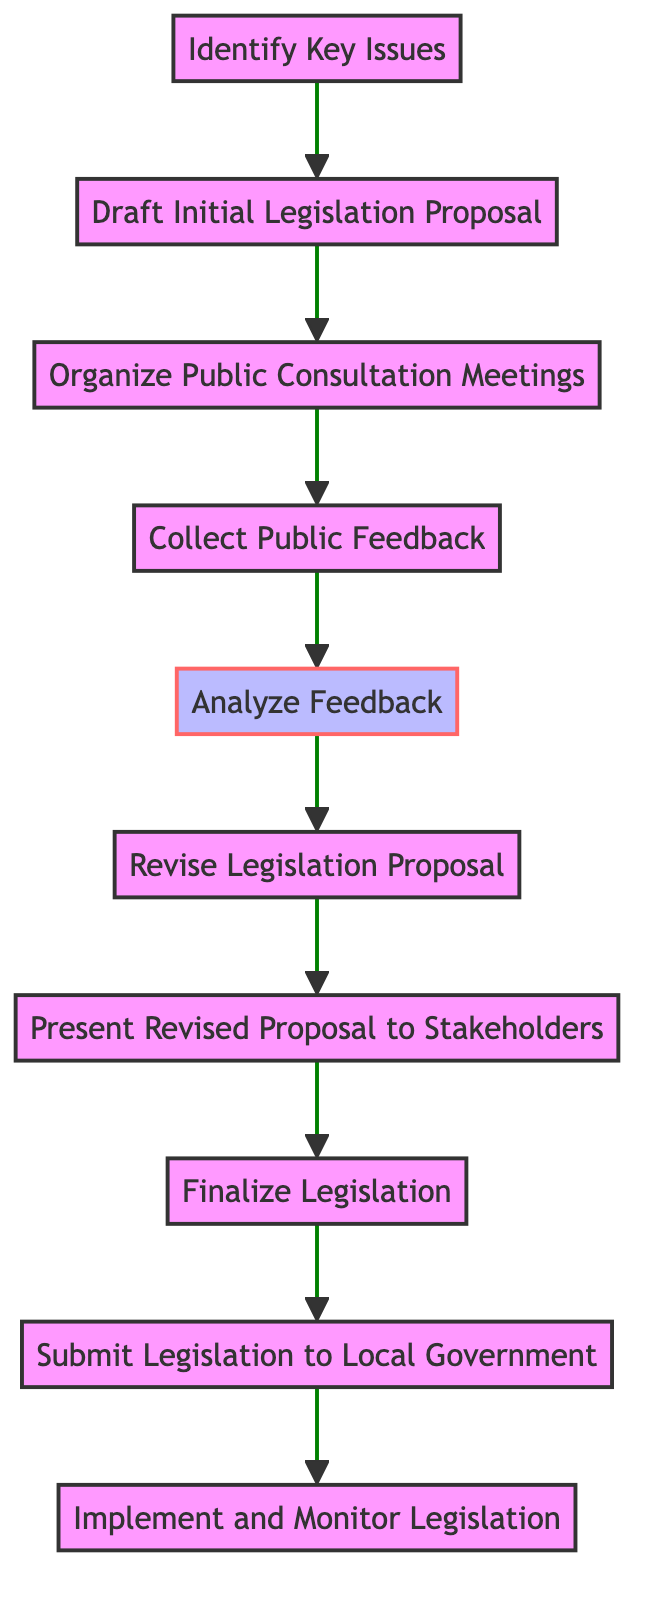What is the first activity in the diagram? The first activity is labeled "Identify Key Issues," which is positioned as the starting point of the flow in the diagram.
Answer: Identify Key Issues How many activities are present in the diagram? By counting the nodes in the diagram, there are ten activities listed, each representing a step in the public consultation and feedback process.
Answer: Ten What is the activity following "Analyze Feedback"? The next activity after "Analyze Feedback" is "Revise Legislation Proposal," which is connected in the flow of activities.
Answer: Revise Legislation Proposal Which activity comes before "Finalize Legislation"? The activity that precedes "Finalize Legislation" is "Present Revised Proposal to Stakeholders," indicating the process of stakeholder engagement before finalizing the document.
Answer: Present Revised Proposal to Stakeholders What is the last activity in the diagram? The last activity is "Implement and Monitor Legislation," marking the final step in the process after submitting the legislation to the local government.
Answer: Implement and Monitor Legislation Which two activities are directly connected without any intermediaries? The activities "Submit Legislation to Local Government" and "Implement and Monitor Legislation" are directly connected, indicating a sequential process with no other steps involved in between.
Answer: Submit Legislation to Local Government and Implement and Monitor Legislation How would you describe the overall flow of the process in the diagram? The flow represents a linear progression, where each activity leads to the next, building upon the previous step from identifying issues to implementation, emphasizing thorough engagement and feedback.
Answer: Linear progression What type of feedback is collected during the "Collect Public Feedback" activity? The feedback collected during this activity encompasses community members' opinions and suggestions, reflecting their perspectives on the initial legislation proposal.
Answer: Community members' opinions and suggestions 